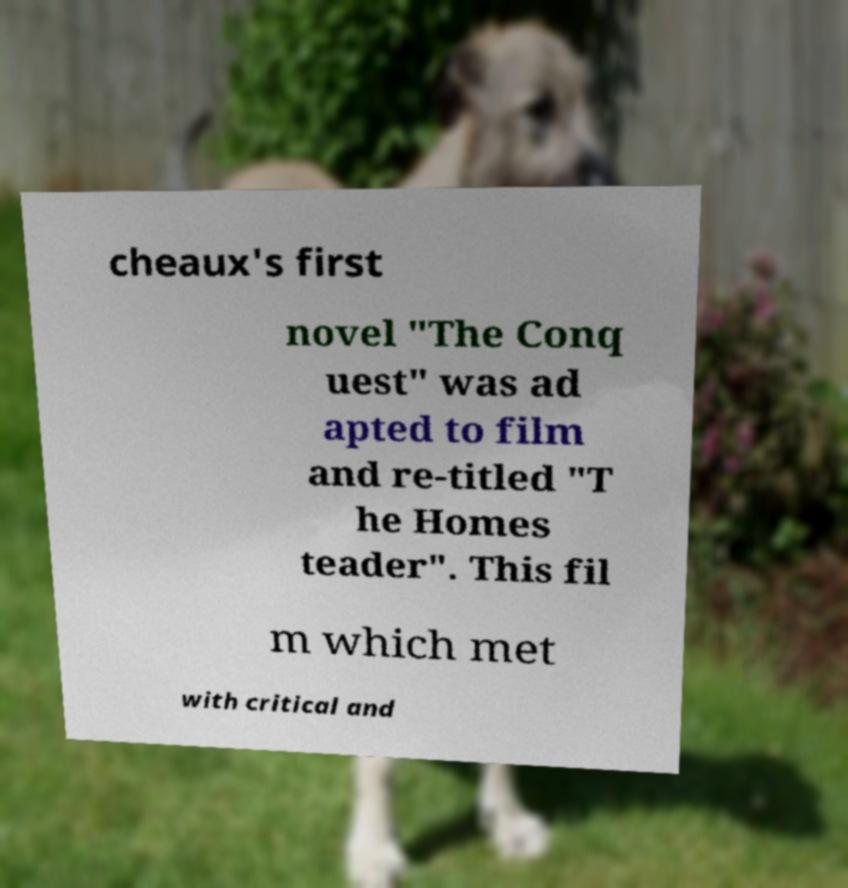What messages or text are displayed in this image? I need them in a readable, typed format. cheaux's first novel "The Conq uest" was ad apted to film and re-titled "T he Homes teader". This fil m which met with critical and 